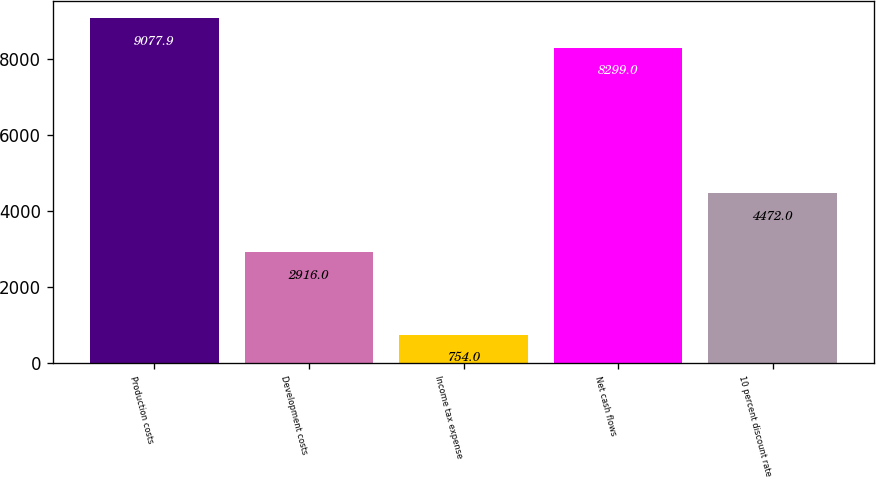<chart> <loc_0><loc_0><loc_500><loc_500><bar_chart><fcel>Production costs<fcel>Development costs<fcel>Income tax expense<fcel>Net cash flows<fcel>10 percent discount rate<nl><fcel>9077.9<fcel>2916<fcel>754<fcel>8299<fcel>4472<nl></chart> 